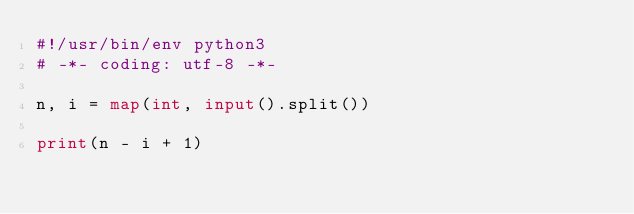<code> <loc_0><loc_0><loc_500><loc_500><_Python_>#!/usr/bin/env python3
# -*- coding: utf-8 -*-

n, i = map(int, input().split())

print(n - i + 1)
</code> 